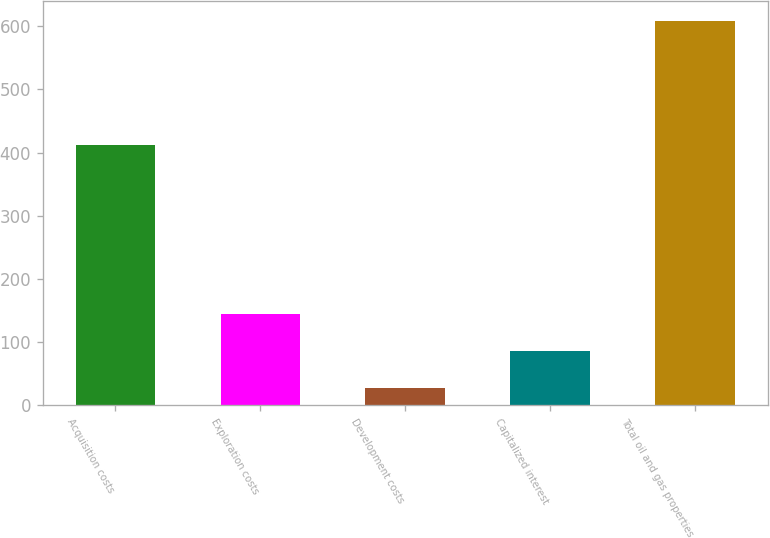Convert chart to OTSL. <chart><loc_0><loc_0><loc_500><loc_500><bar_chart><fcel>Acquisition costs<fcel>Exploration costs<fcel>Development costs<fcel>Capitalized interest<fcel>Total oil and gas properties<nl><fcel>412<fcel>144.2<fcel>28<fcel>86.1<fcel>609<nl></chart> 